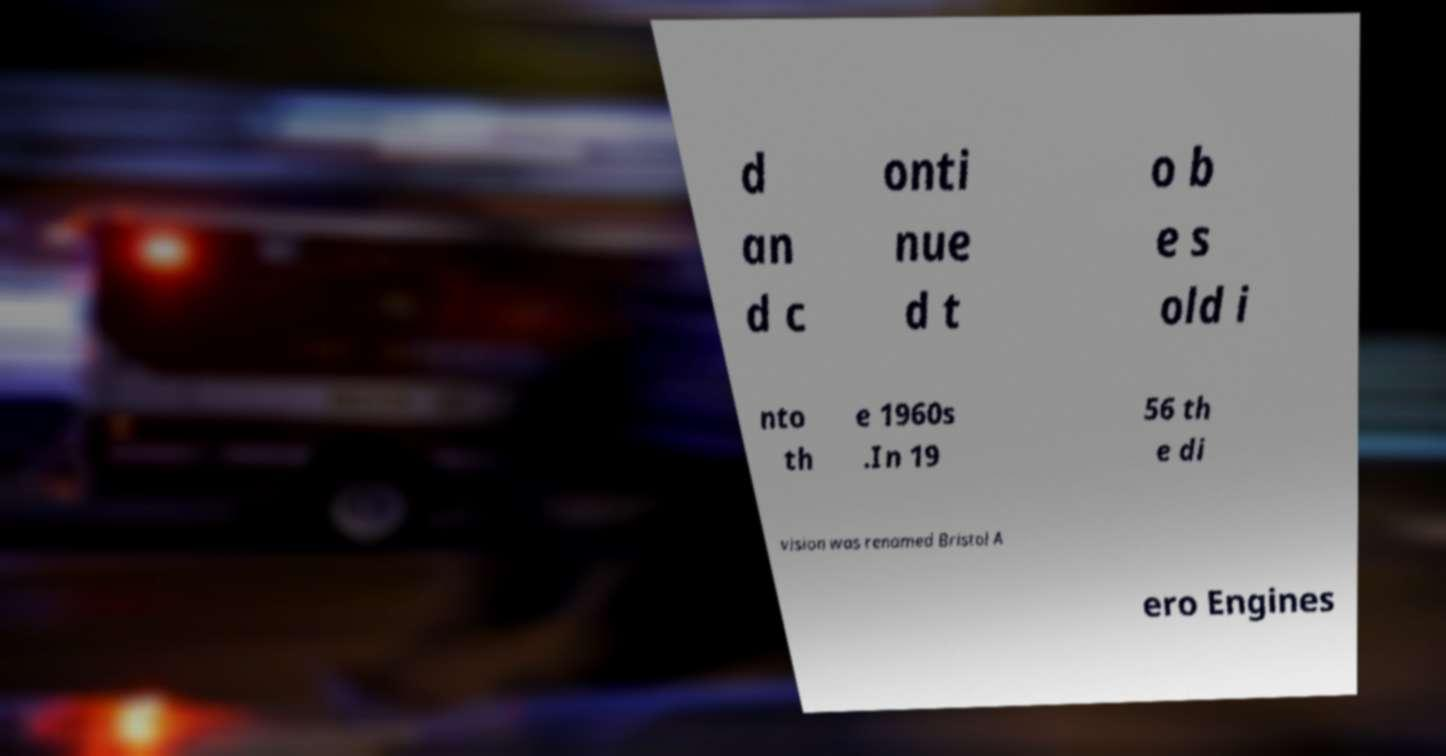There's text embedded in this image that I need extracted. Can you transcribe it verbatim? d an d c onti nue d t o b e s old i nto th e 1960s .In 19 56 th e di vision was renamed Bristol A ero Engines 